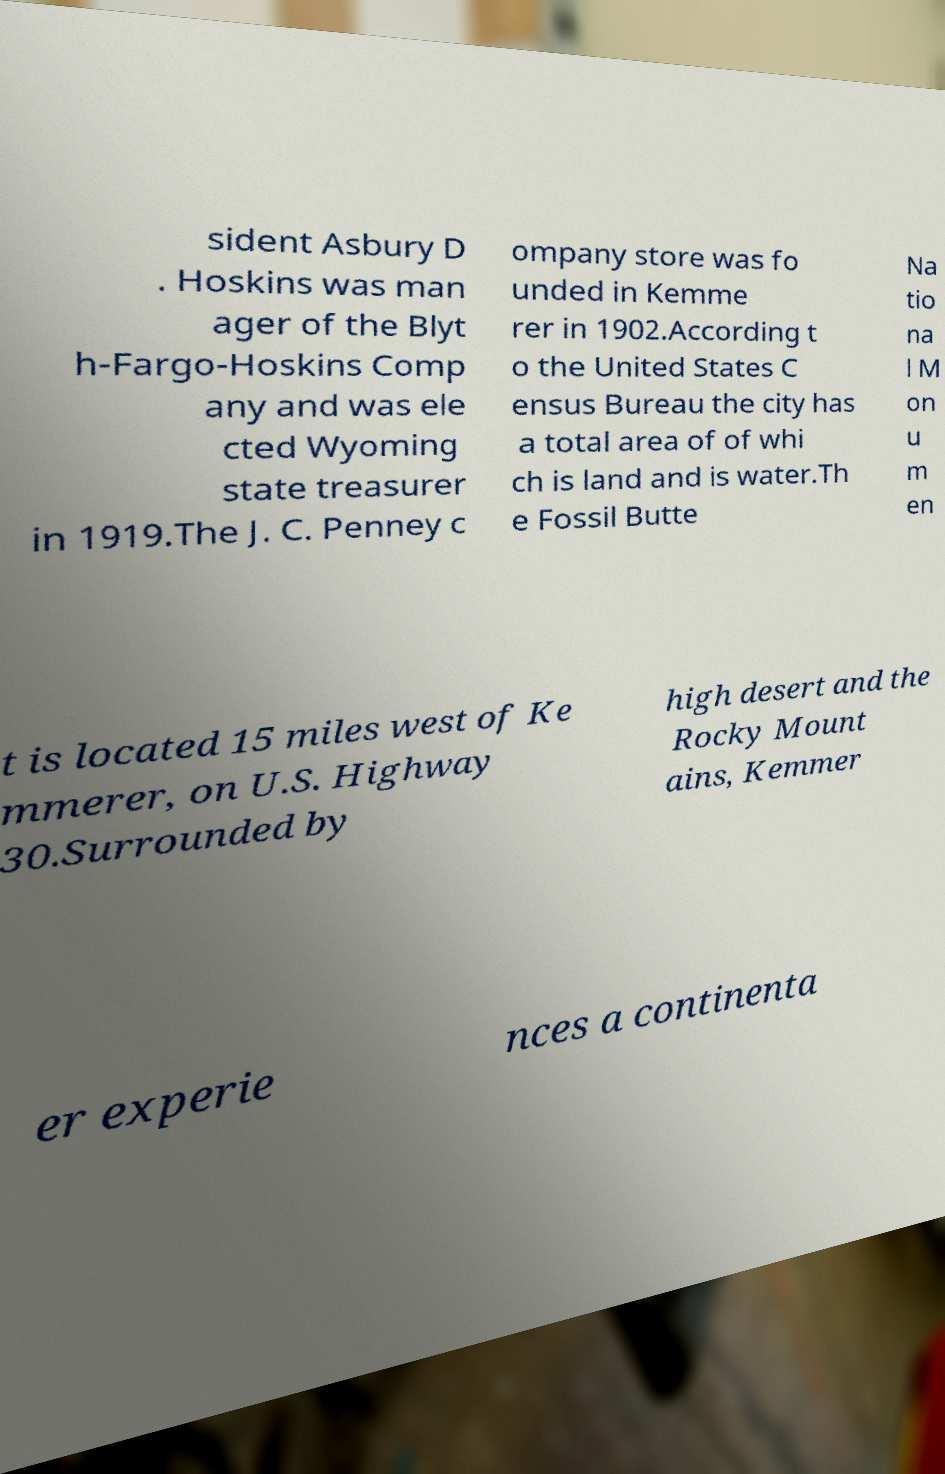There's text embedded in this image that I need extracted. Can you transcribe it verbatim? sident Asbury D . Hoskins was man ager of the Blyt h-Fargo-Hoskins Comp any and was ele cted Wyoming state treasurer in 1919.The J. C. Penney c ompany store was fo unded in Kemme rer in 1902.According t o the United States C ensus Bureau the city has a total area of of whi ch is land and is water.Th e Fossil Butte Na tio na l M on u m en t is located 15 miles west of Ke mmerer, on U.S. Highway 30.Surrounded by high desert and the Rocky Mount ains, Kemmer er experie nces a continenta 